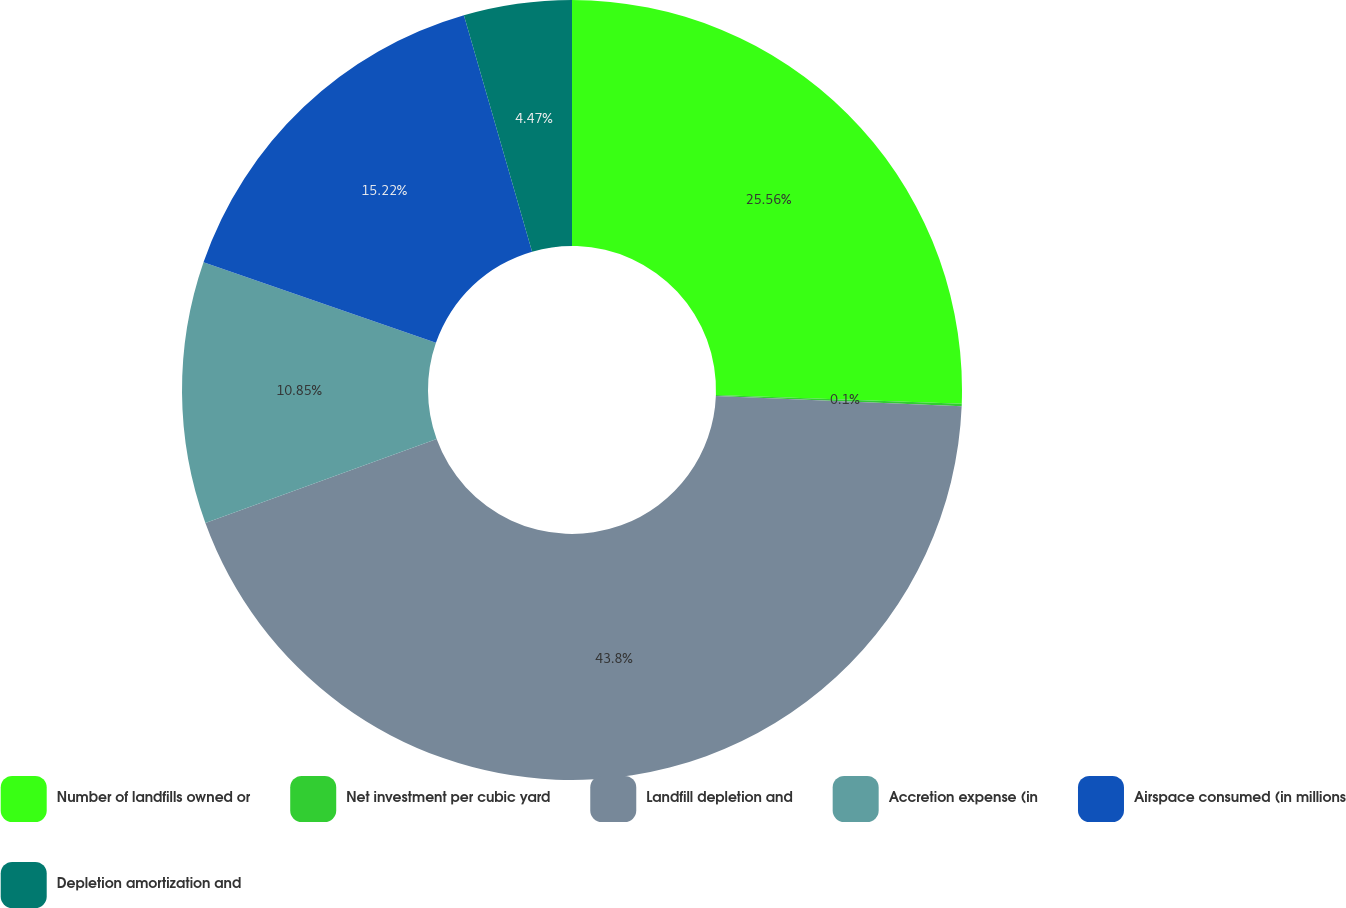Convert chart. <chart><loc_0><loc_0><loc_500><loc_500><pie_chart><fcel>Number of landfills owned or<fcel>Net investment per cubic yard<fcel>Landfill depletion and<fcel>Accretion expense (in<fcel>Airspace consumed (in millions<fcel>Depletion amortization and<nl><fcel>25.56%<fcel>0.1%<fcel>43.8%<fcel>10.85%<fcel>15.22%<fcel>4.47%<nl></chart> 